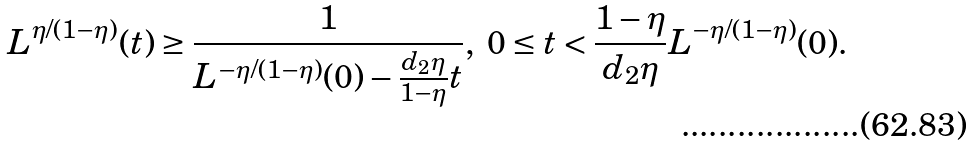Convert formula to latex. <formula><loc_0><loc_0><loc_500><loc_500>L ^ { \eta / ( 1 - \eta ) } ( t ) \geq \frac { 1 } { L ^ { - \eta / ( 1 - \eta ) } ( 0 ) - \frac { d _ { 2 } \eta } { 1 - \eta } t } , \text { } 0 \leq t < \frac { 1 - \eta } { d _ { 2 } \eta } L ^ { - \eta / ( 1 - \eta ) } ( 0 ) .</formula> 